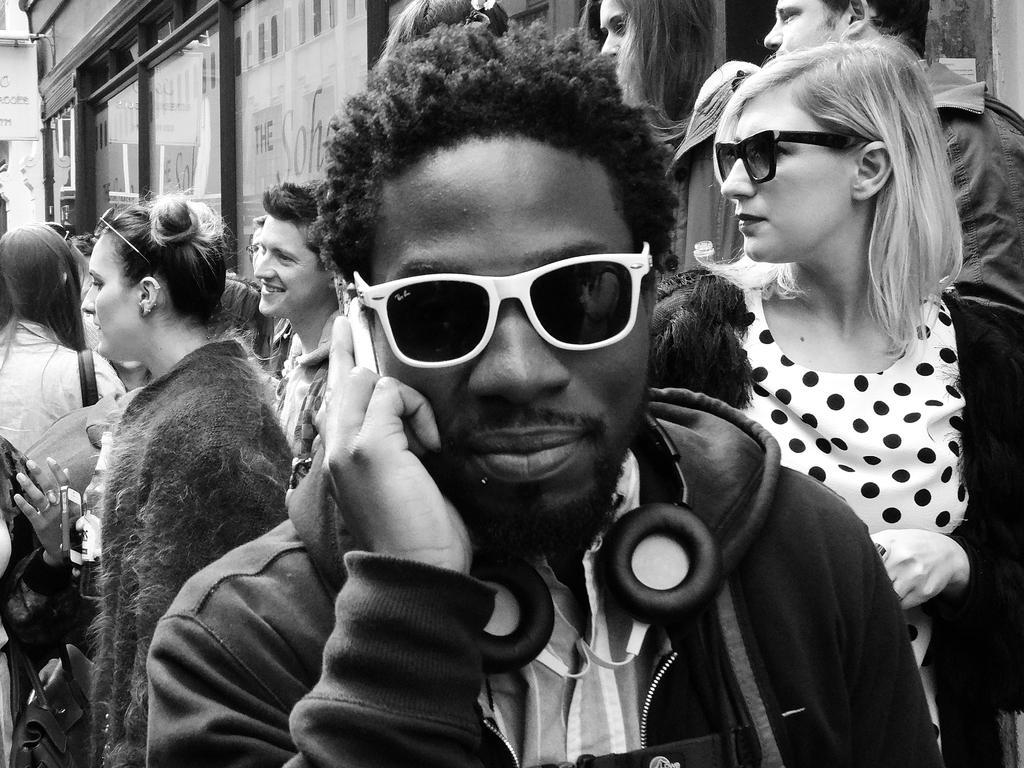Could you give a brief overview of what you see in this image? It is a black and white image, there are few people standing beside a store and in the front there is a man, he is wearing a headset and holding a mobile phone. 